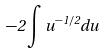Convert formula to latex. <formula><loc_0><loc_0><loc_500><loc_500>- 2 \int u ^ { - 1 / 2 } d u</formula> 